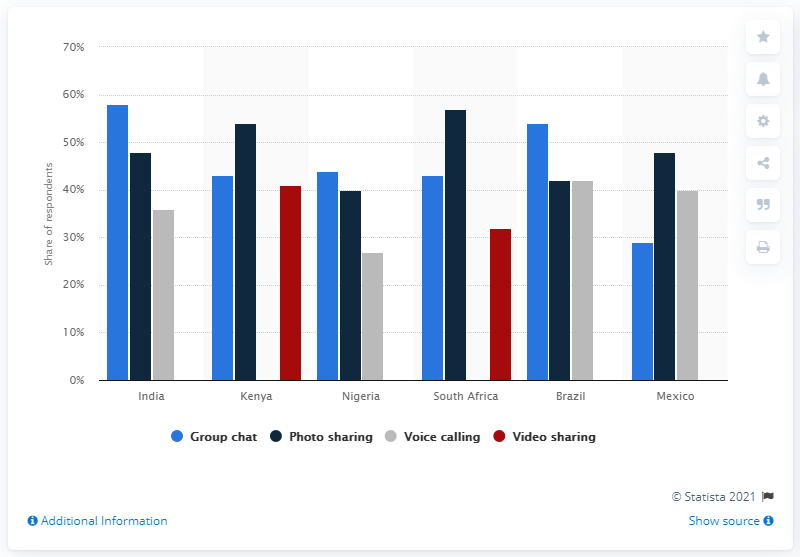Draw attention to some important aspects in this diagram. Mexico has the highest percentage of mobile messenger users among all countries. 